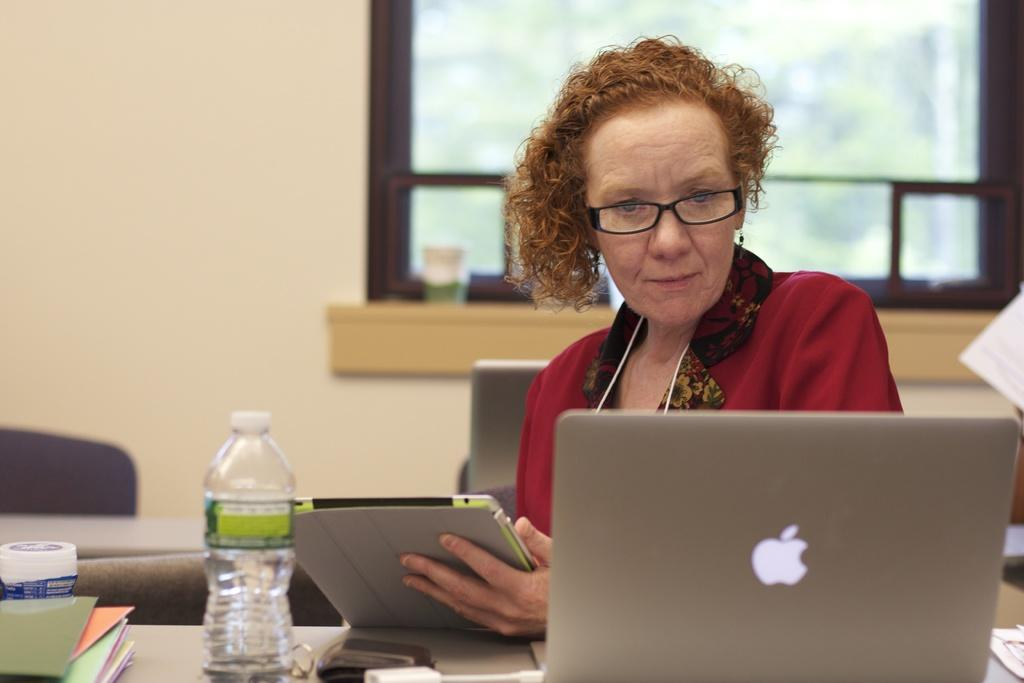Who is present in the image? There is a woman in the image. What is the woman doing in the image? The woman is sitting in the image. What is the woman holding in her hands? The woman is holding a book in her hands. What is on the table in front of the woman? There is a laptop on the table, and there are other objects on the table as well. What can be seen through the window at the back of the scene? Unfortunately, the facts provided do not mention what can be seen through the window. What type of spark can be seen coming from the laptop in the image? There is no spark coming from the laptop in the image. What kind of birds are flying outside the window in the image? There are no birds visible in the image, and the facts provided do not mention any birds. 